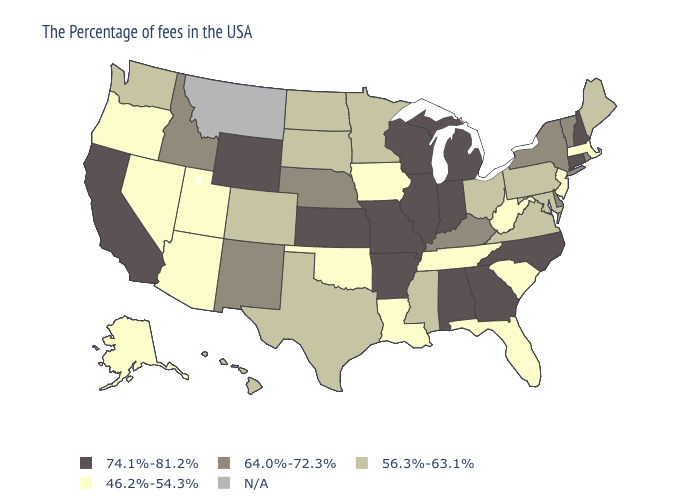Name the states that have a value in the range 64.0%-72.3%?
Write a very short answer. Rhode Island, Vermont, New York, Delaware, Kentucky, Nebraska, New Mexico, Idaho. Which states have the highest value in the USA?
Quick response, please. New Hampshire, Connecticut, North Carolina, Georgia, Michigan, Indiana, Alabama, Wisconsin, Illinois, Missouri, Arkansas, Kansas, Wyoming, California. Among the states that border Missouri , which have the highest value?
Concise answer only. Illinois, Arkansas, Kansas. Among the states that border Oklahoma , which have the lowest value?
Quick response, please. Texas, Colorado. What is the highest value in the USA?
Keep it brief. 74.1%-81.2%. What is the lowest value in the USA?
Short answer required. 46.2%-54.3%. Name the states that have a value in the range 64.0%-72.3%?
Keep it brief. Rhode Island, Vermont, New York, Delaware, Kentucky, Nebraska, New Mexico, Idaho. What is the highest value in states that border South Carolina?
Keep it brief. 74.1%-81.2%. Which states have the lowest value in the West?
Be succinct. Utah, Arizona, Nevada, Oregon, Alaska. What is the highest value in states that border Florida?
Concise answer only. 74.1%-81.2%. What is the value of Minnesota?
Keep it brief. 56.3%-63.1%. How many symbols are there in the legend?
Keep it brief. 5. Does Vermont have the lowest value in the Northeast?
Answer briefly. No. Name the states that have a value in the range 64.0%-72.3%?
Short answer required. Rhode Island, Vermont, New York, Delaware, Kentucky, Nebraska, New Mexico, Idaho. What is the highest value in the USA?
Write a very short answer. 74.1%-81.2%. 